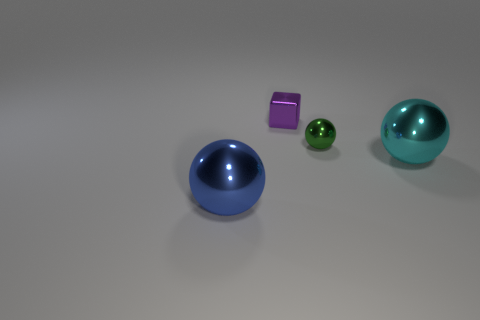Can you tell me the colors of the objects starting from the left? From left to right, the objects display a progression of colors: the first is blue, the second is purple, the third is green, and the fourth is a shade of teal or cyan. 